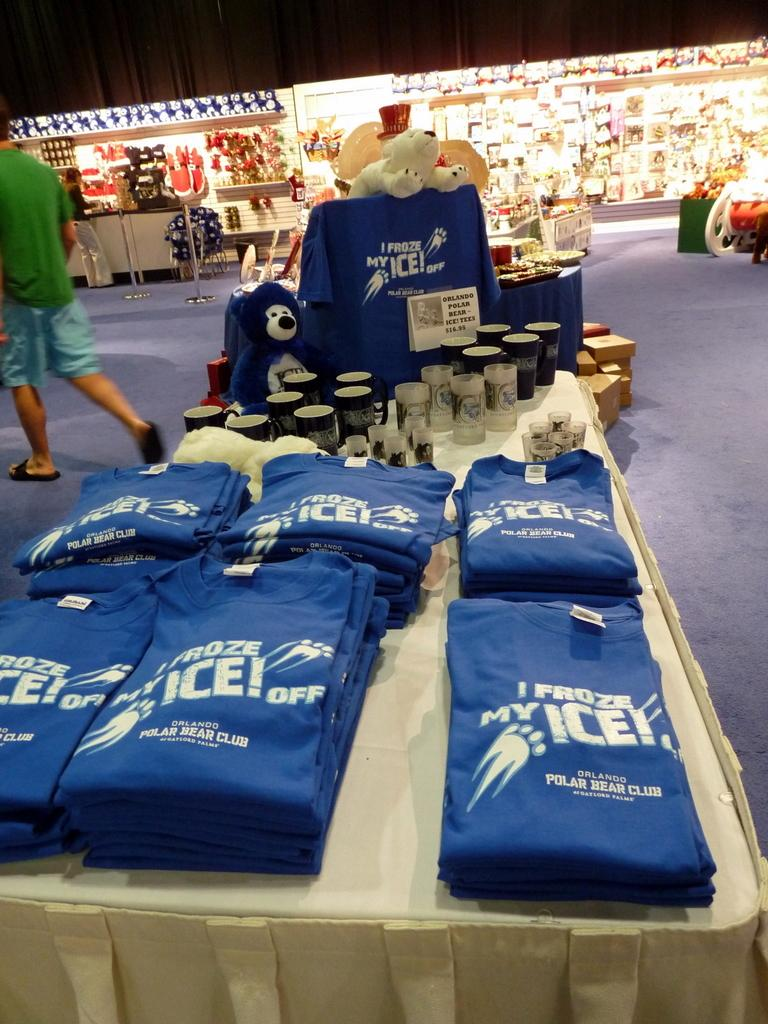<image>
Describe the image concisely. A display in a store that has Orlando Polar Bear Club merchandise on it. 